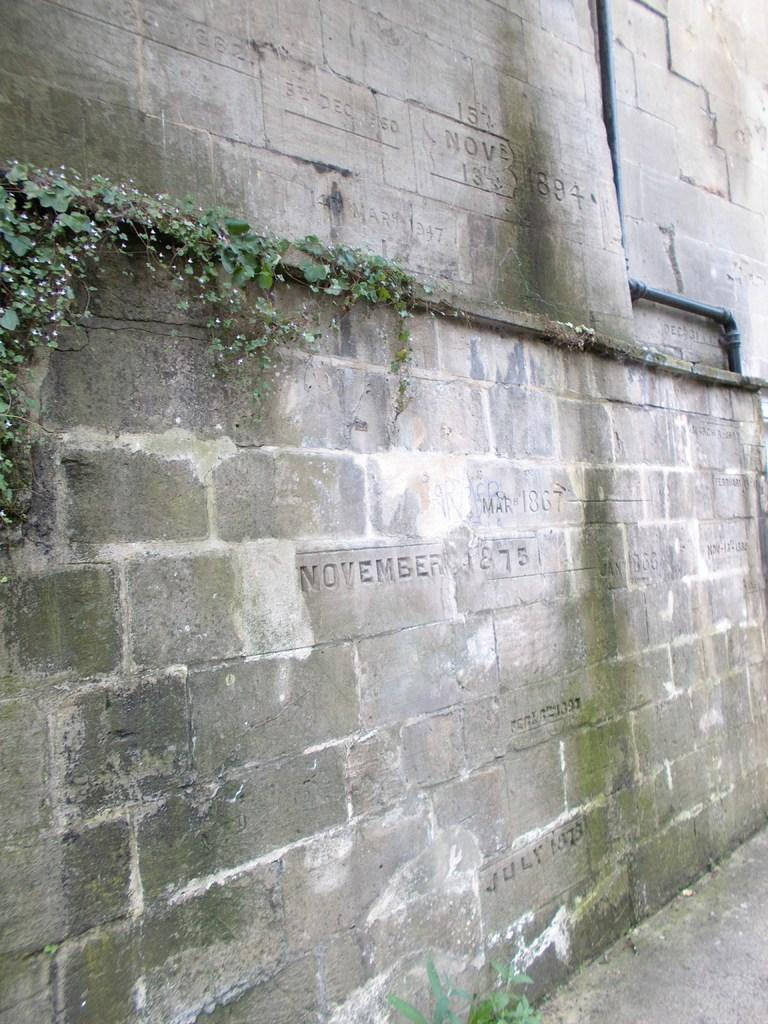What type of structure is visible in the image? There is a brick wall in the image. What is written or depicted on the bricks? There is text on the bricks in the image. What can be seen on the right side of the image? There is a pipe on the right side of the image. What type of vegetation is growing on the wall in the image? There are creepers on the wall on the left side of the image. What type of industry is depicted in the image? There is no industry depicted in the image; it features a brick wall with text, a pipe, and creepers. How many tanks are visible in the image? There are no tanks present in the image. 